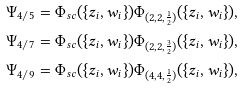Convert formula to latex. <formula><loc_0><loc_0><loc_500><loc_500>\Psi _ { 4 / 5 } & = \Phi _ { s c } ( \{ z _ { i } , w _ { i } \} ) \Phi _ { ( 2 , 2 , \frac { 1 } { 2 } ) } ( \{ z _ { i } , w _ { i } \} ) , \\ \Psi _ { 4 / 7 } & = \Phi _ { s c } ( \{ z _ { i } , w _ { i } \} ) \Phi _ { ( 2 , 2 , \frac { 3 } { 2 } ) } ( \{ z _ { i } , w _ { i } \} ) , \\ \Psi _ { 4 / 9 } & = \Phi _ { s c } ( \{ z _ { i } , w _ { i } \} ) \Phi _ { ( 4 , 4 , \frac { 1 } { 2 } ) } ( \{ z _ { i } , w _ { i } \} ) ,</formula> 